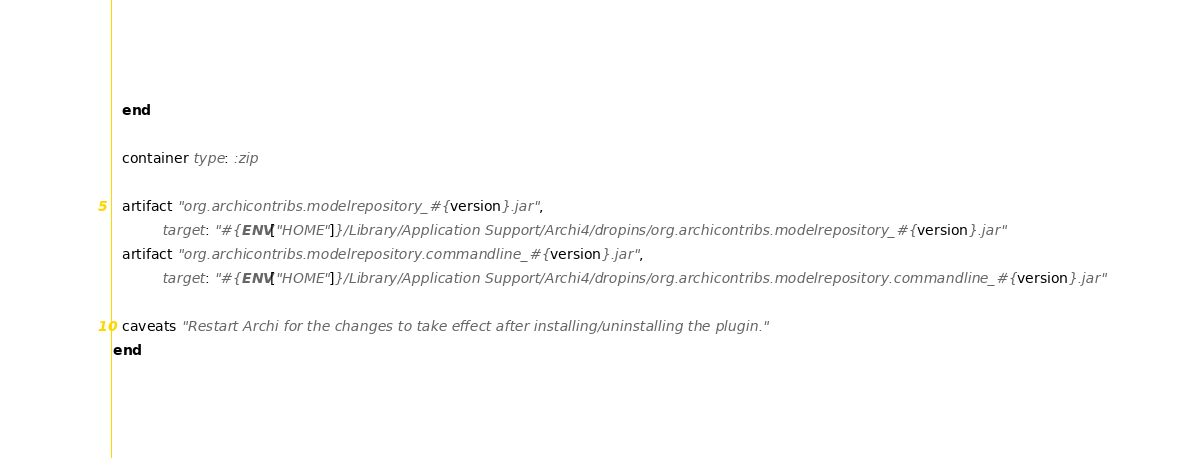<code> <loc_0><loc_0><loc_500><loc_500><_Ruby_>  end

  container type: :zip

  artifact "org.archicontribs.modelrepository_#{version}.jar",
           target: "#{ENV["HOME"]}/Library/Application Support/Archi4/dropins/org.archicontribs.modelrepository_#{version}.jar"
  artifact "org.archicontribs.modelrepository.commandline_#{version}.jar",
           target: "#{ENV["HOME"]}/Library/Application Support/Archi4/dropins/org.archicontribs.modelrepository.commandline_#{version}.jar"

  caveats "Restart Archi for the changes to take effect after installing/uninstalling the plugin."
end
</code> 